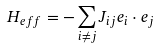Convert formula to latex. <formula><loc_0><loc_0><loc_500><loc_500>H _ { e f f } = - \sum _ { i \ne j } J _ { i j } { e } _ { i } \cdot { e } _ { j }</formula> 